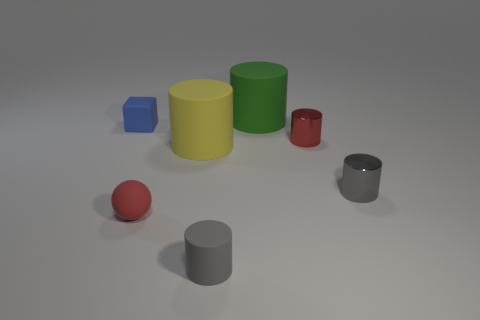Subtract all gray cylinders. How many were subtracted if there are1gray cylinders left? 1 Subtract all green cylinders. How many cylinders are left? 4 Subtract all big green matte cylinders. How many cylinders are left? 4 Subtract all brown cylinders. Subtract all yellow blocks. How many cylinders are left? 5 Add 3 large yellow metallic cylinders. How many objects exist? 10 Subtract all balls. How many objects are left? 6 Add 7 small red shiny cylinders. How many small red shiny cylinders exist? 8 Subtract 2 gray cylinders. How many objects are left? 5 Subtract all large brown balls. Subtract all big things. How many objects are left? 5 Add 5 gray cylinders. How many gray cylinders are left? 7 